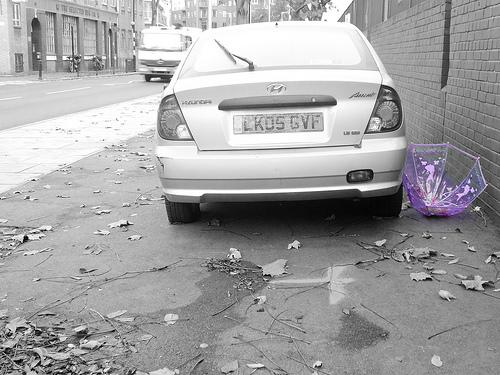Question: where are bricks?
Choices:
A. On a fireplace.
B. On a fire pit.
C. On a wall.
D. In a cart.
Answer with the letter. Answer: C Question: when was the picture taken?
Choices:
A. Evening.
B. Early morning.
C. Daytime.
D. Late afternoon.
Answer with the letter. Answer: C Question: where is a license plate?
Choices:
A. On the back of the car.
B. On the front of the car.
C. In the store.
D. At home.
Answer with the letter. Answer: A Question: where is a windshield wiper?
Choices:
A. On car's back window.
B. In the trash can.
C. On the windshield.
D. In its packaging.
Answer with the letter. Answer: A Question: what color is the umbrella?
Choices:
A. Purple.
B. Red.
C. Blue.
D. Pink.
Answer with the letter. Answer: A Question: where was the photo taken?
Choices:
A. On a boat.
B. In the ZOO.
C. In the amusement park.
D. On a city street.
Answer with the letter. Answer: D 